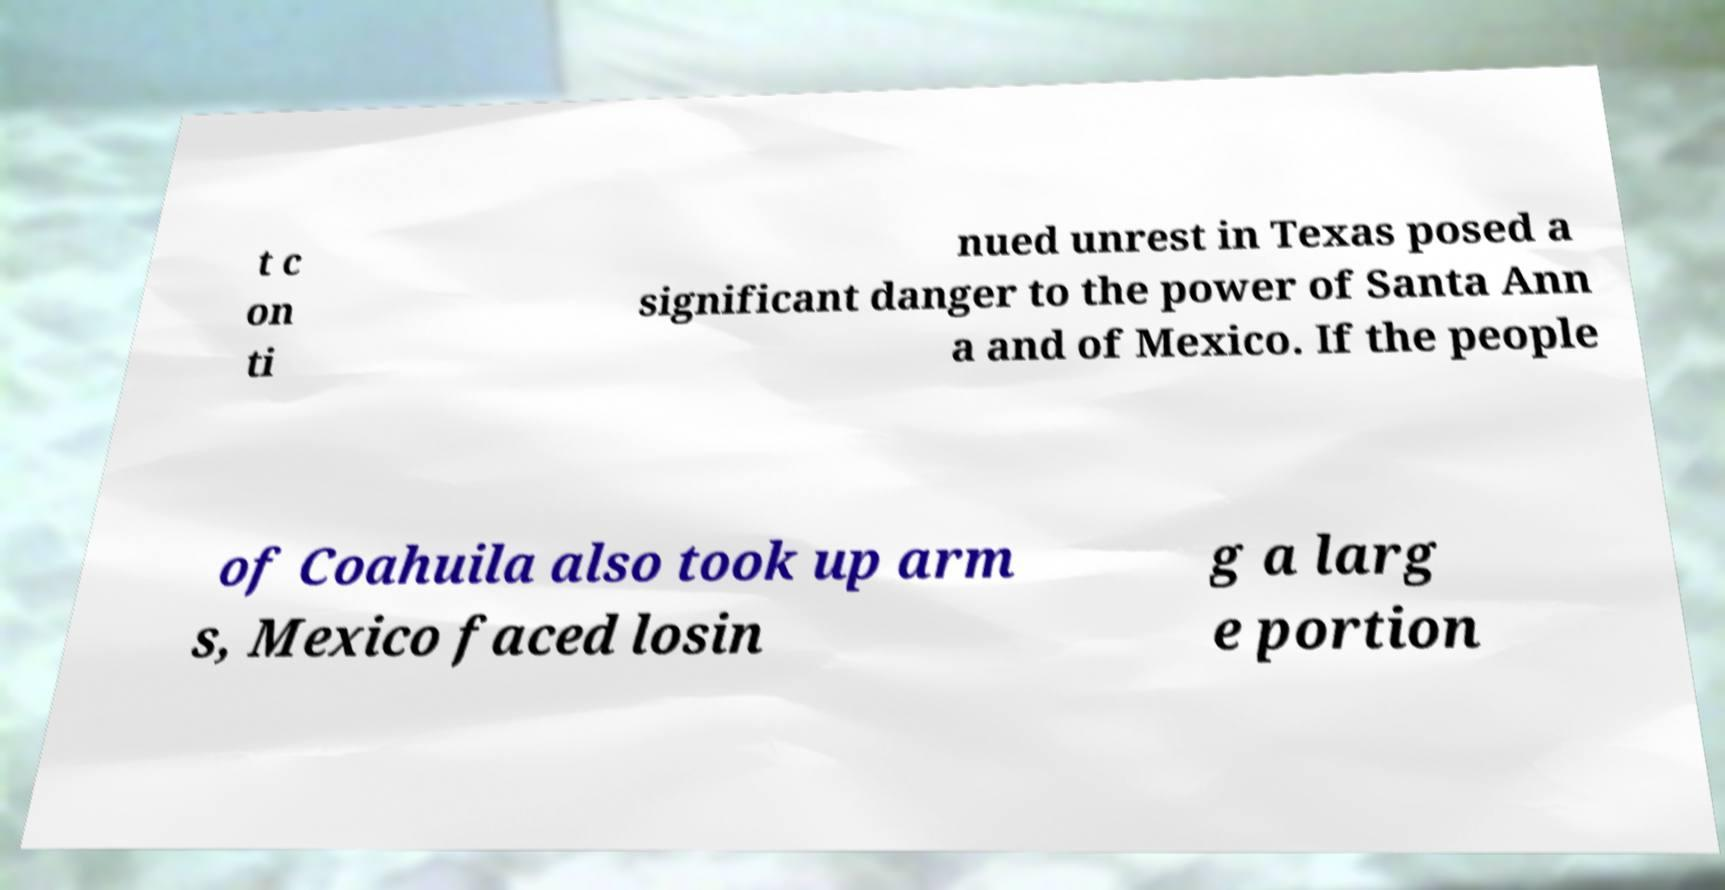There's text embedded in this image that I need extracted. Can you transcribe it verbatim? t c on ti nued unrest in Texas posed a significant danger to the power of Santa Ann a and of Mexico. If the people of Coahuila also took up arm s, Mexico faced losin g a larg e portion 